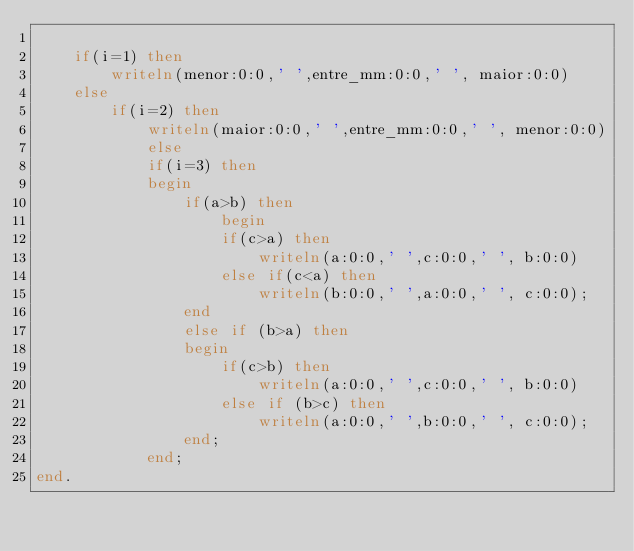<code> <loc_0><loc_0><loc_500><loc_500><_Pascal_>
	if(i=1) then
		writeln(menor:0:0,' ',entre_mm:0:0,' ', maior:0:0)
	else
		if(i=2) then
			writeln(maior:0:0,' ',entre_mm:0:0,' ', menor:0:0)
        	else 
 			if(i=3) then
			begin
				if(a>b) then
			       	begin
					if(c>a) then
						writeln(a:0:0,' ',c:0:0,' ', b:0:0)
					else if(c<a) then
						writeln(b:0:0,' ',a:0:0,' ', c:0:0);
				end
				else if (b>a) then
				begin 
					if(c>b) then
						writeln(a:0:0,' ',c:0:0,' ', b:0:0)
					else if (b>c) then
						writeln(a:0:0,' ',b:0:0,' ', c:0:0);
				end;
			end;
end.
</code> 